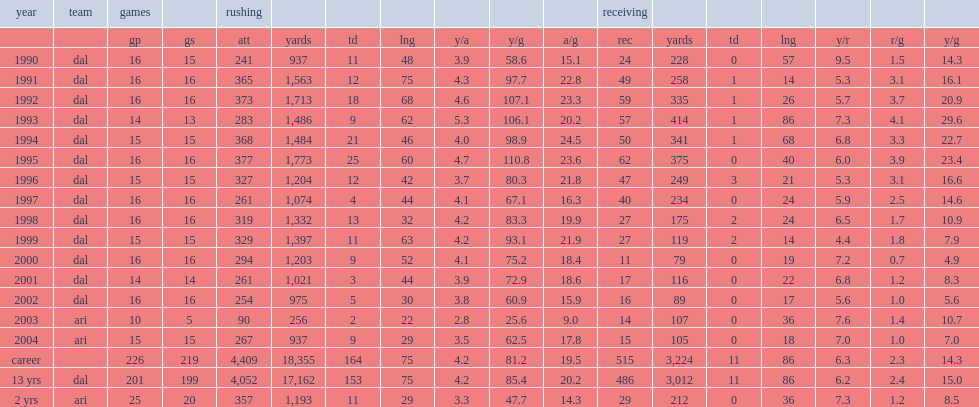How many rushing yards did emmitt smith get in 1991? 1563.0. 